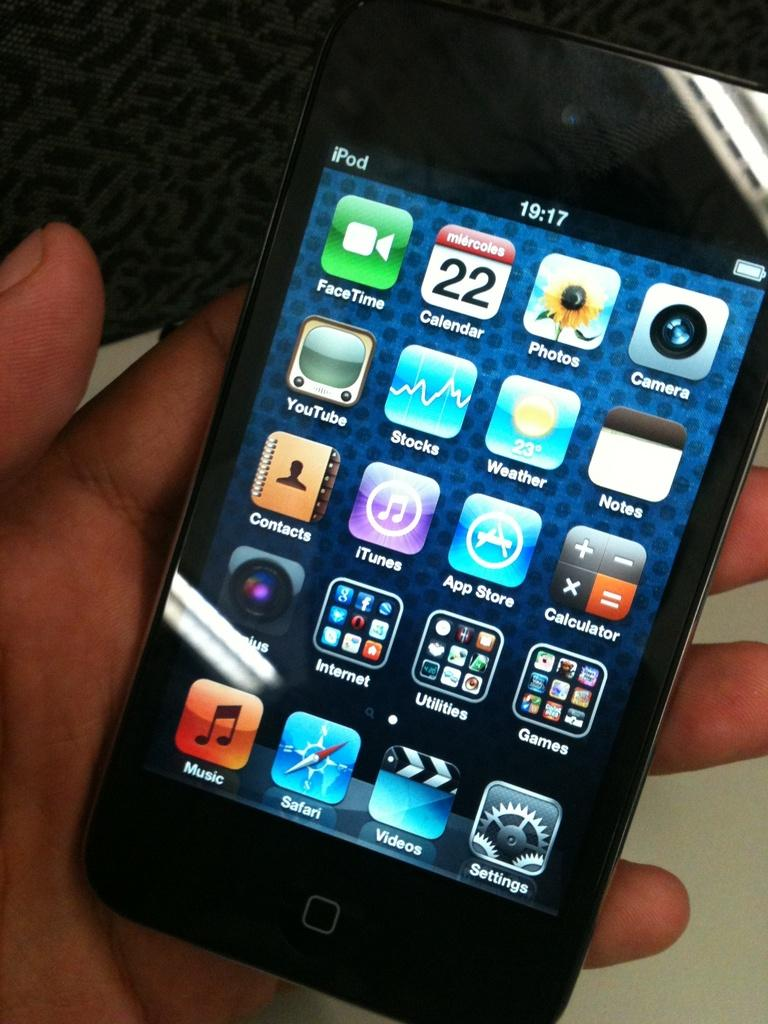<image>
Offer a succinct explanation of the picture presented. an icon that has the word music on it 